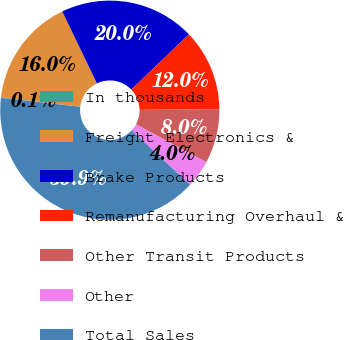Convert chart to OTSL. <chart><loc_0><loc_0><loc_500><loc_500><pie_chart><fcel>In thousands<fcel>Freight Electronics &<fcel>Brake Products<fcel>Remanufacturing Overhaul &<fcel>Other Transit Products<fcel>Other<fcel>Total Sales<nl><fcel>0.06%<fcel>15.99%<fcel>19.98%<fcel>12.01%<fcel>8.03%<fcel>4.04%<fcel>39.9%<nl></chart> 